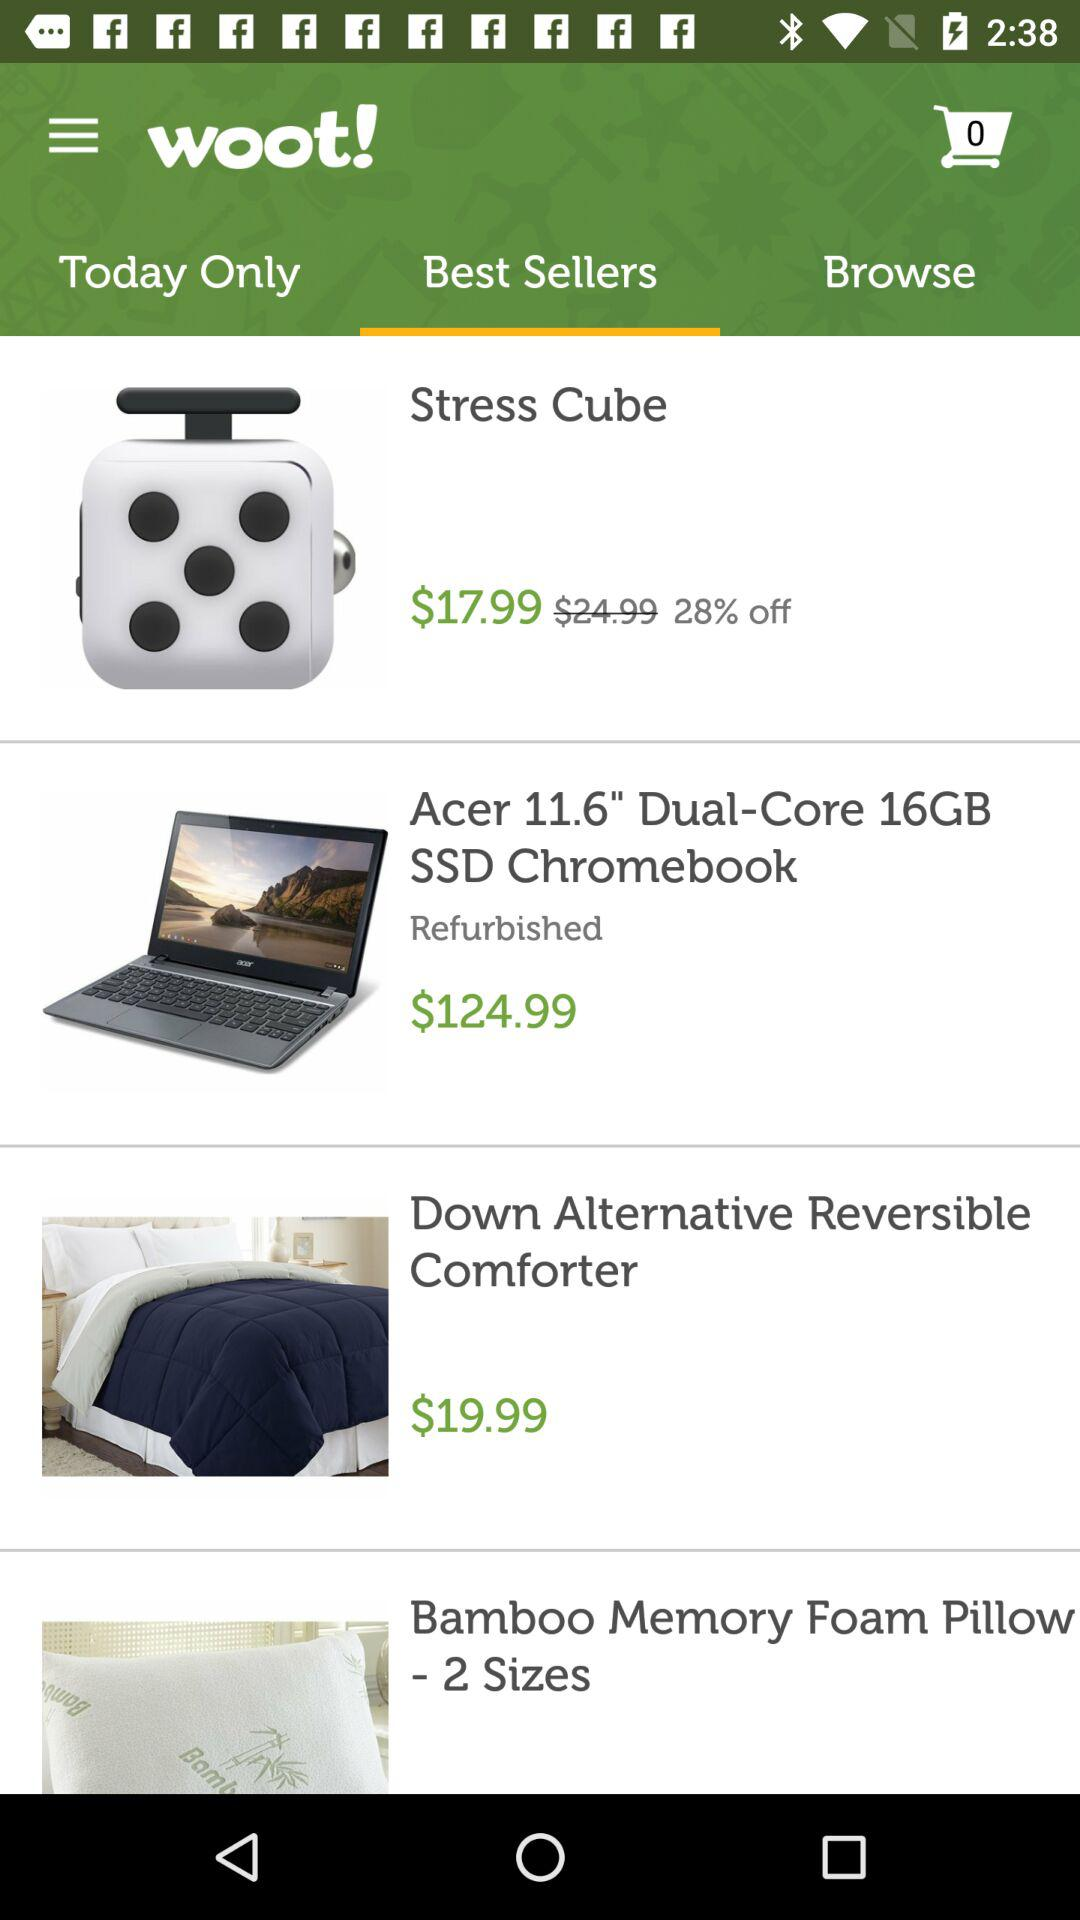What is the price of the "Acer 11.6" Dual-Core 16GB SSD Chromebook"? The price is $124.99. 